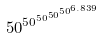<formula> <loc_0><loc_0><loc_500><loc_500>5 0 ^ { 5 0 ^ { 5 0 ^ { 5 0 ^ { 5 0 ^ { 6 . 8 3 9 } } } } }</formula> 